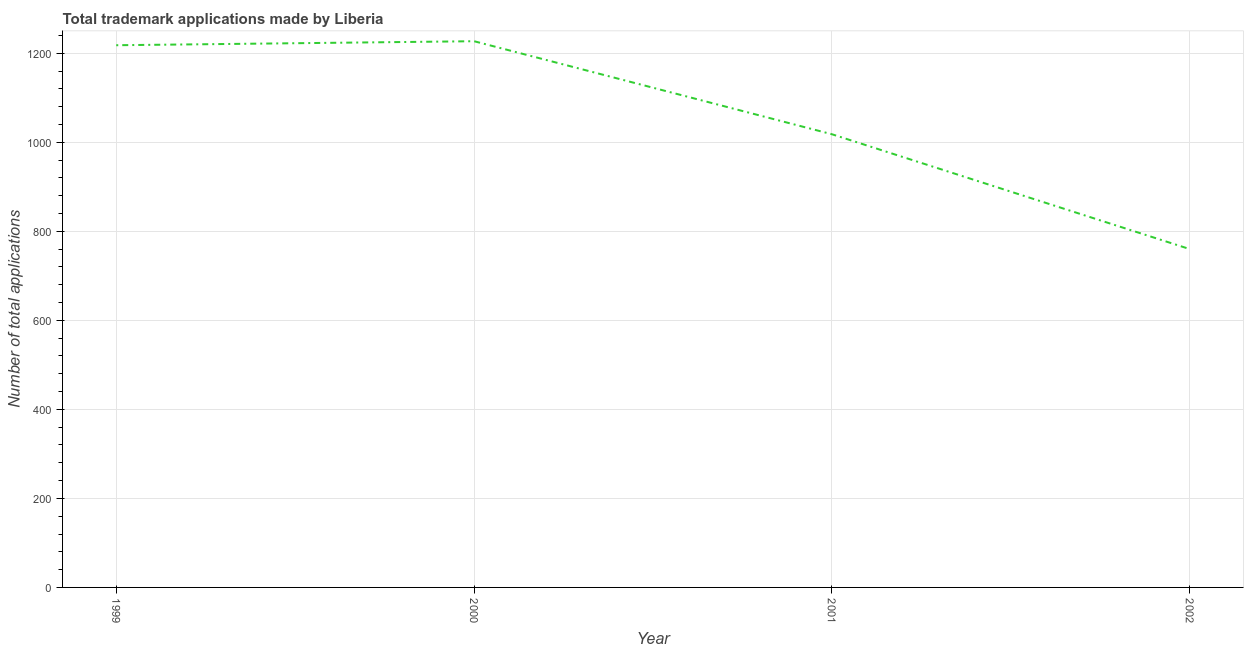What is the number of trademark applications in 2000?
Ensure brevity in your answer.  1227. Across all years, what is the maximum number of trademark applications?
Offer a terse response. 1227. Across all years, what is the minimum number of trademark applications?
Provide a succinct answer. 760. What is the sum of the number of trademark applications?
Make the answer very short. 4223. What is the difference between the number of trademark applications in 1999 and 2002?
Make the answer very short. 458. What is the average number of trademark applications per year?
Keep it short and to the point. 1055.75. What is the median number of trademark applications?
Make the answer very short. 1118. In how many years, is the number of trademark applications greater than 920 ?
Keep it short and to the point. 3. What is the ratio of the number of trademark applications in 1999 to that in 2001?
Offer a very short reply. 1.2. Is the difference between the number of trademark applications in 2000 and 2002 greater than the difference between any two years?
Your response must be concise. Yes. What is the difference between the highest and the second highest number of trademark applications?
Your answer should be very brief. 9. Is the sum of the number of trademark applications in 2001 and 2002 greater than the maximum number of trademark applications across all years?
Your answer should be compact. Yes. What is the difference between the highest and the lowest number of trademark applications?
Offer a terse response. 467. In how many years, is the number of trademark applications greater than the average number of trademark applications taken over all years?
Make the answer very short. 2. How many lines are there?
Provide a short and direct response. 1. What is the difference between two consecutive major ticks on the Y-axis?
Ensure brevity in your answer.  200. Are the values on the major ticks of Y-axis written in scientific E-notation?
Keep it short and to the point. No. Does the graph contain any zero values?
Provide a succinct answer. No. Does the graph contain grids?
Provide a short and direct response. Yes. What is the title of the graph?
Keep it short and to the point. Total trademark applications made by Liberia. What is the label or title of the Y-axis?
Provide a succinct answer. Number of total applications. What is the Number of total applications of 1999?
Give a very brief answer. 1218. What is the Number of total applications in 2000?
Offer a very short reply. 1227. What is the Number of total applications of 2001?
Your answer should be compact. 1018. What is the Number of total applications in 2002?
Offer a very short reply. 760. What is the difference between the Number of total applications in 1999 and 2000?
Provide a short and direct response. -9. What is the difference between the Number of total applications in 1999 and 2001?
Your answer should be compact. 200. What is the difference between the Number of total applications in 1999 and 2002?
Offer a very short reply. 458. What is the difference between the Number of total applications in 2000 and 2001?
Provide a succinct answer. 209. What is the difference between the Number of total applications in 2000 and 2002?
Provide a succinct answer. 467. What is the difference between the Number of total applications in 2001 and 2002?
Give a very brief answer. 258. What is the ratio of the Number of total applications in 1999 to that in 2000?
Your answer should be compact. 0.99. What is the ratio of the Number of total applications in 1999 to that in 2001?
Make the answer very short. 1.2. What is the ratio of the Number of total applications in 1999 to that in 2002?
Ensure brevity in your answer.  1.6. What is the ratio of the Number of total applications in 2000 to that in 2001?
Provide a short and direct response. 1.21. What is the ratio of the Number of total applications in 2000 to that in 2002?
Offer a very short reply. 1.61. What is the ratio of the Number of total applications in 2001 to that in 2002?
Your answer should be compact. 1.34. 